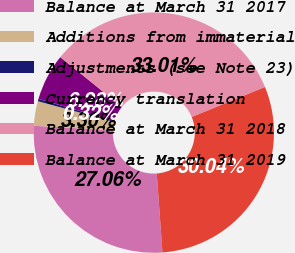Convert chart to OTSL. <chart><loc_0><loc_0><loc_500><loc_500><pie_chart><fcel>Balance at March 31 2017<fcel>Additions from immaterial<fcel>Adjustments (see Note 23)<fcel>Currency translation<fcel>Balance at March 31 2018<fcel>Balance at March 31 2019<nl><fcel>27.06%<fcel>3.3%<fcel>0.32%<fcel>6.28%<fcel>33.01%<fcel>30.04%<nl></chart> 